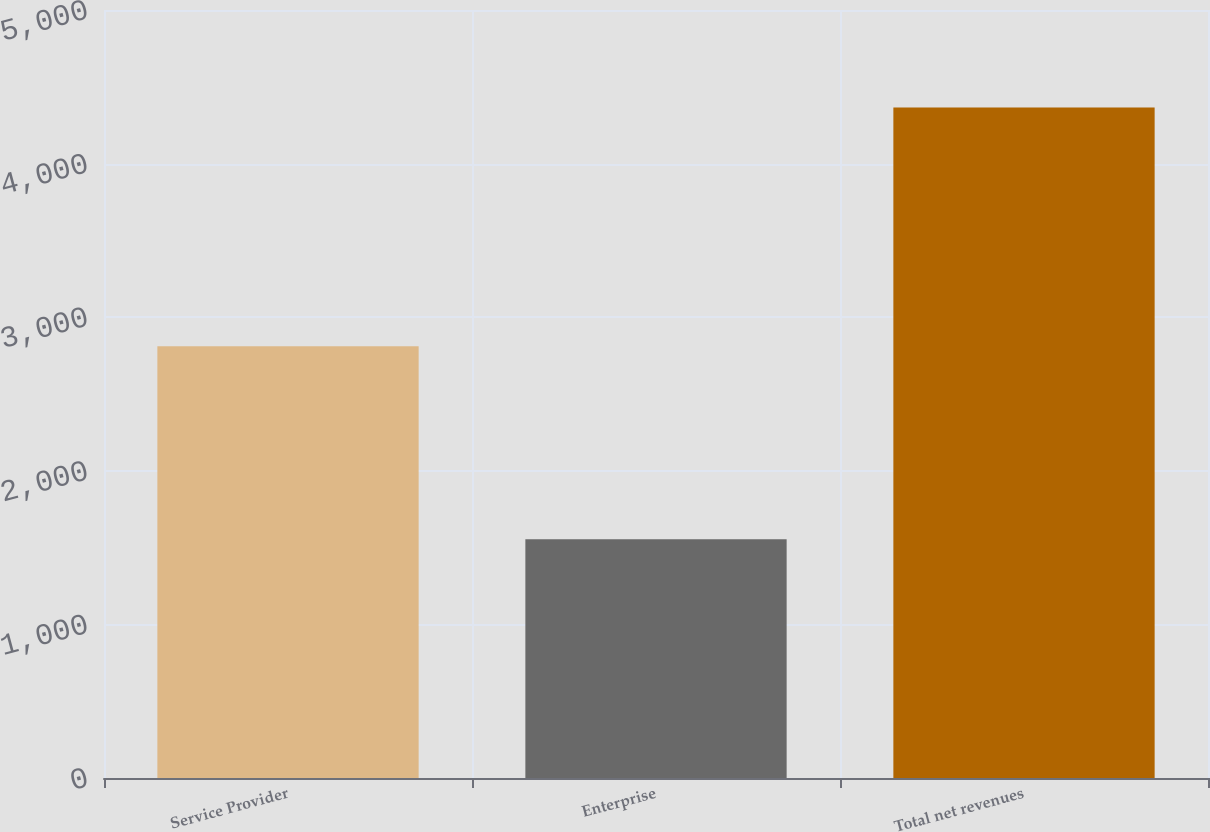<chart> <loc_0><loc_0><loc_500><loc_500><bar_chart><fcel>Service Provider<fcel>Enterprise<fcel>Total net revenues<nl><fcel>2811.2<fcel>1554.2<fcel>4365.4<nl></chart> 